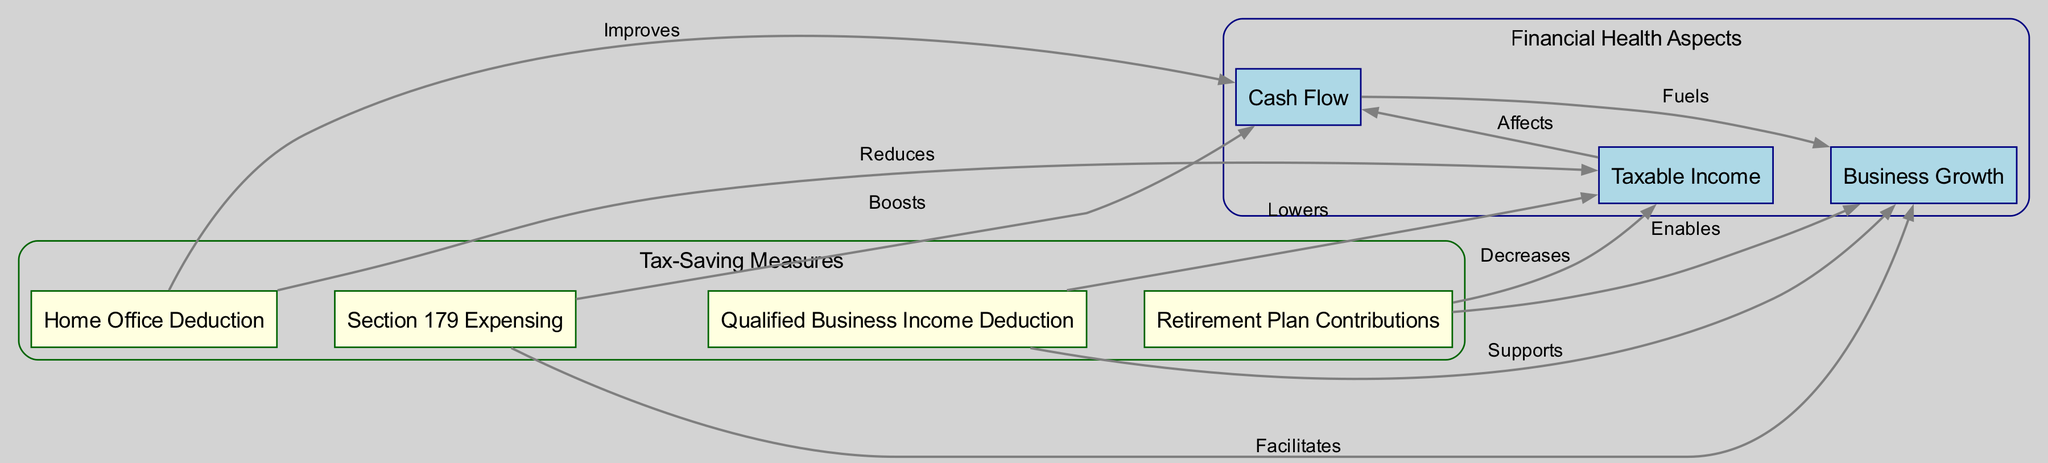What are the tax-saving measures depicted in the diagram? The diagram lists four tax-saving measures: Home Office Deduction, Section 179 Expensing, Qualified Business Income Deduction, and Retirement Plan Contributions. These measures are represented as separate nodes, each labeled accordingly.
Answer: Home Office Deduction, Section 179 Expensing, Qualified Business Income Deduction, Retirement Plan Contributions How many edges are there in total? The diagram has a total of ten edges connecting the various nodes, which represent the relationships between the tax-saving measures and aspects of financial health. Each connection is labeled with the effect of one node on another, further confirming the number of edges present.
Answer: 10 Which measure affects taxable income the most? Both the Home Office Deduction and the Retirement Plan Contributions have edges leading to the "Taxable Income" node indicating they reduce or decrease it. However, since retirement contributions typically have a substantial impact on reducing taxable income over time, we can deduce that it's particularly significant.
Answer: Retirement Plan Contributions What is the relationship between Cash Flow and Business Growth? In the diagram, there is a direct edge from Cash Flow to Business Growth labeled "Fuels." This indicates that an increase in Cash Flow directly supports or facilitates the growth of the business, thus showcasing a positive relationship.
Answer: Fuels How does the Qualified Business Income Deduction impact taxable income? The diagram illustrates a direct edge from Qualified Business Income Deduction to taxable income labeled "Lowers," indicating a direct downward effect, meaning this measure effectively reduces the amount of taxable income.
Answer: Lowers What do the nodes with light blue color represent? The nodes colored light blue in the diagram represent aspects of financial health, which include Cash Flow, Taxable Income, and Business Growth. This distinction in color indicates their role as financial metrics rather than tax-saving measures.
Answer: Financial health aspects Which tax-saving measure has the potential to boost cash flow? Both the Section 179 Expensing and Home Office Deduction affect Cash Flow positively. Section 179 Expensing is specifically noted to "Boost" Cash Flow, suggesting a more direct impact than the Home Office Deduction, which "Improves" it.
Answer: Section 179 Expensing How many tax-saving measures support business growth? Three tax-saving measures—Section 179 Expensing, Qualified Business Income Deduction, and Retirement Plan Contributions—have direct edges leading to the Business Growth node, each indicating their supportive role in facilitating growth.
Answer: Three 